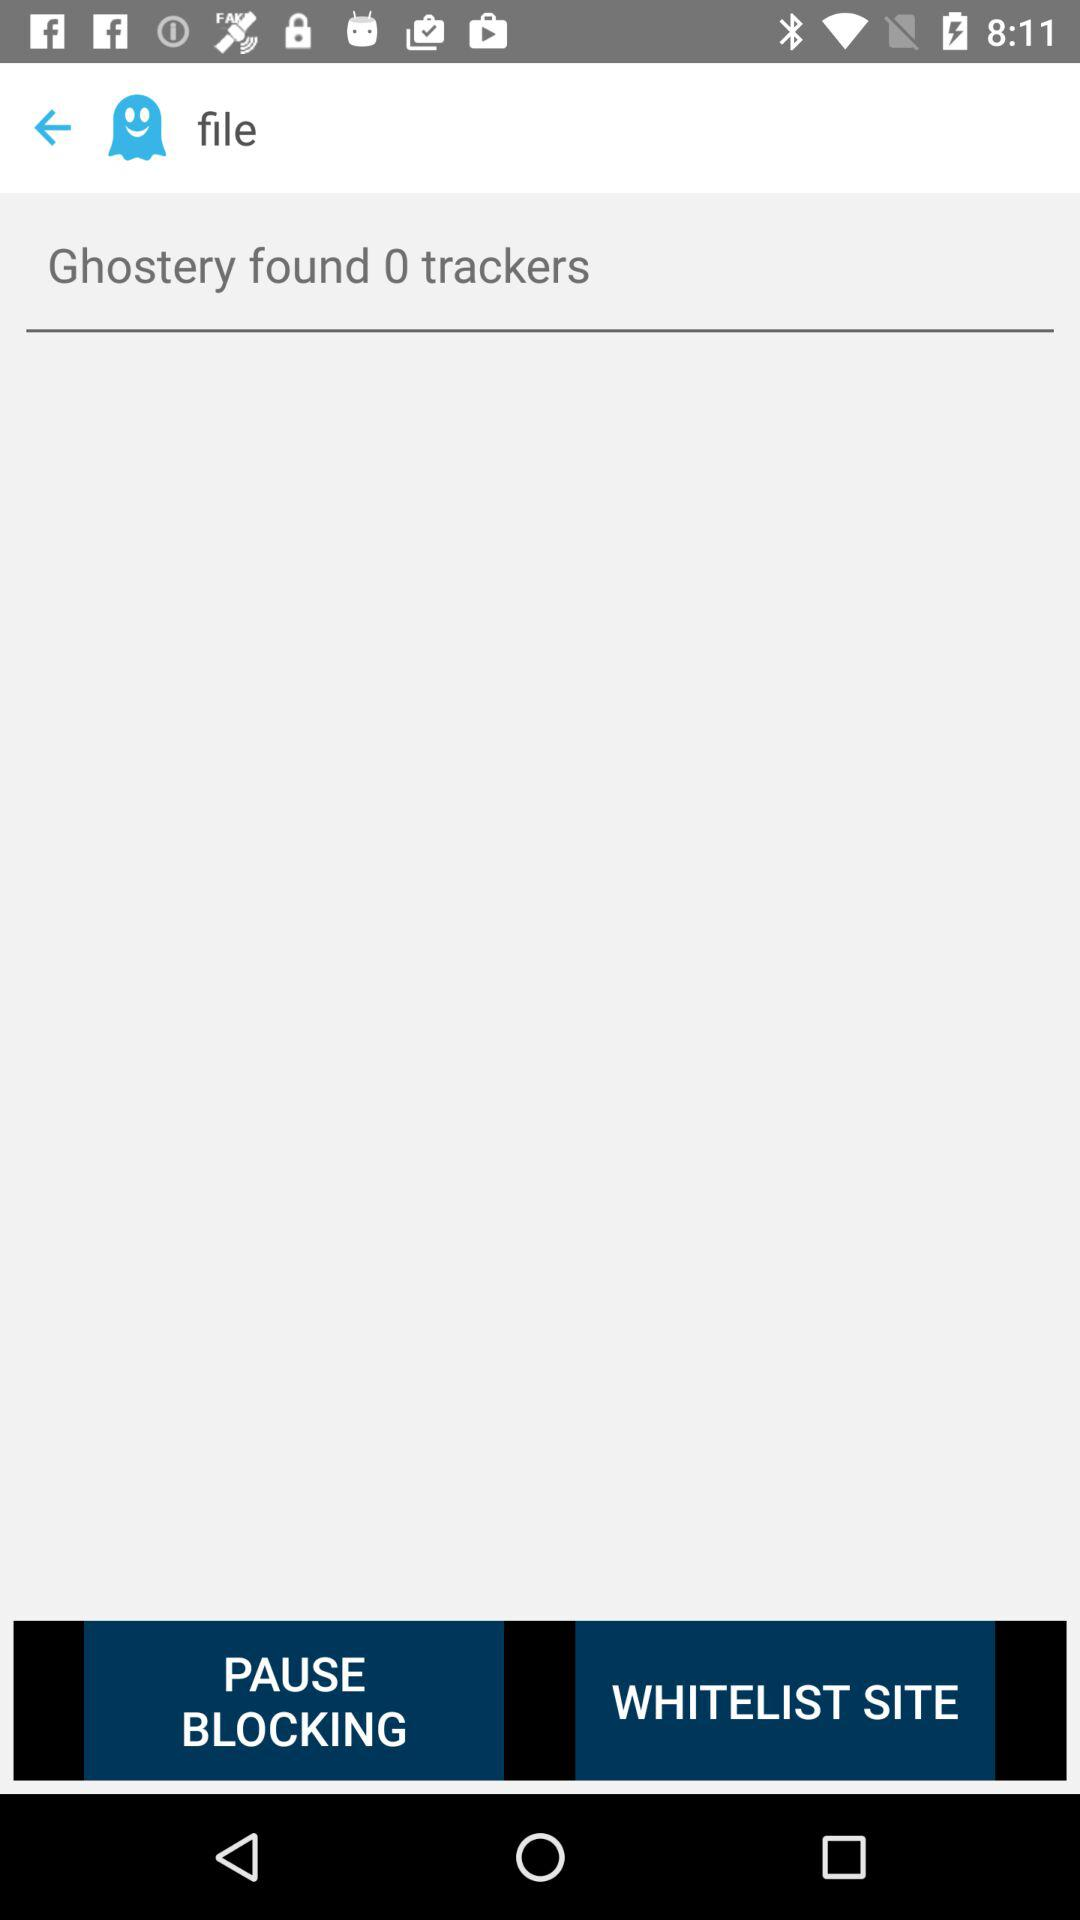What's the number of trackers found by "Ghostery"? The number of trackers found by "Ghostery" is 0. 